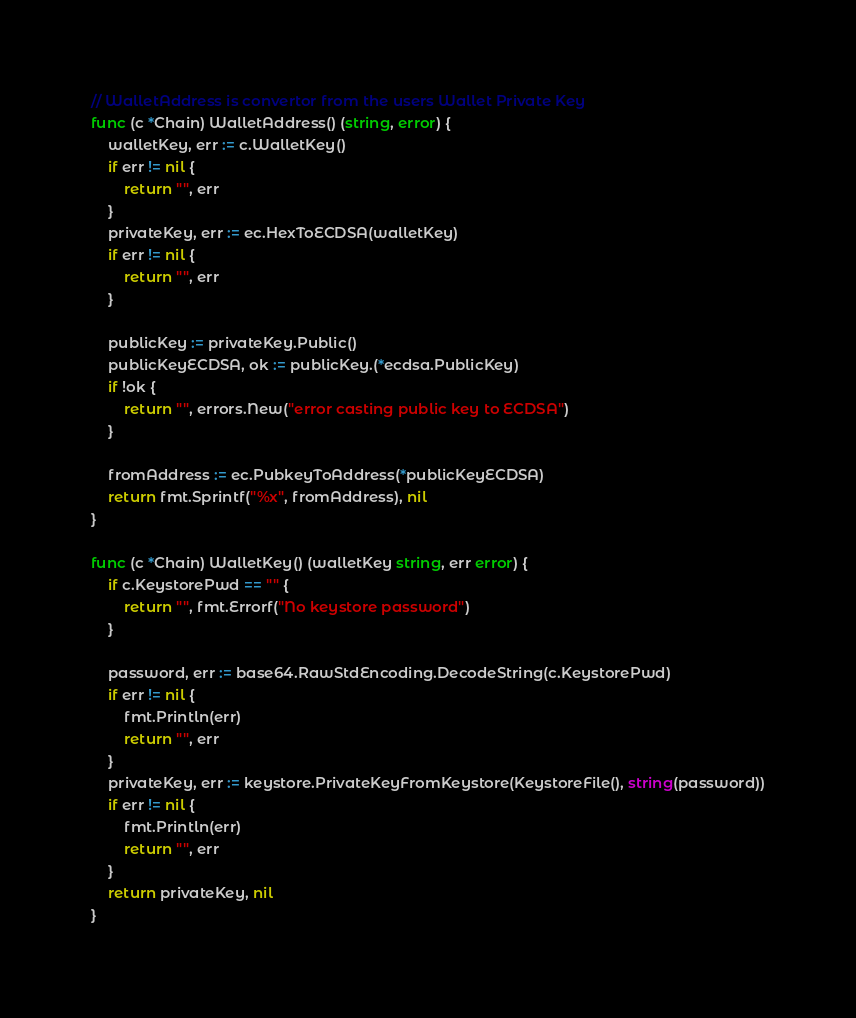<code> <loc_0><loc_0><loc_500><loc_500><_Go_>
// WalletAddress is convertor from the users Wallet Private Key
func (c *Chain) WalletAddress() (string, error) {
	walletKey, err := c.WalletKey()
	if err != nil {
		return "", err
	}
	privateKey, err := ec.HexToECDSA(walletKey)
	if err != nil {
		return "", err
	}

	publicKey := privateKey.Public()
	publicKeyECDSA, ok := publicKey.(*ecdsa.PublicKey)
	if !ok {
		return "", errors.New("error casting public key to ECDSA")
	}

	fromAddress := ec.PubkeyToAddress(*publicKeyECDSA)
	return fmt.Sprintf("%x", fromAddress), nil
}

func (c *Chain) WalletKey() (walletKey string, err error) {
	if c.KeystorePwd == "" {
		return "", fmt.Errorf("No keystore password")
	}

	password, err := base64.RawStdEncoding.DecodeString(c.KeystorePwd)
	if err != nil {
		fmt.Println(err)
		return "", err
	}
	privateKey, err := keystore.PrivateKeyFromKeystore(KeystoreFile(), string(password))
	if err != nil {
		fmt.Println(err)
		return "", err
	}
	return privateKey, nil
}
</code> 